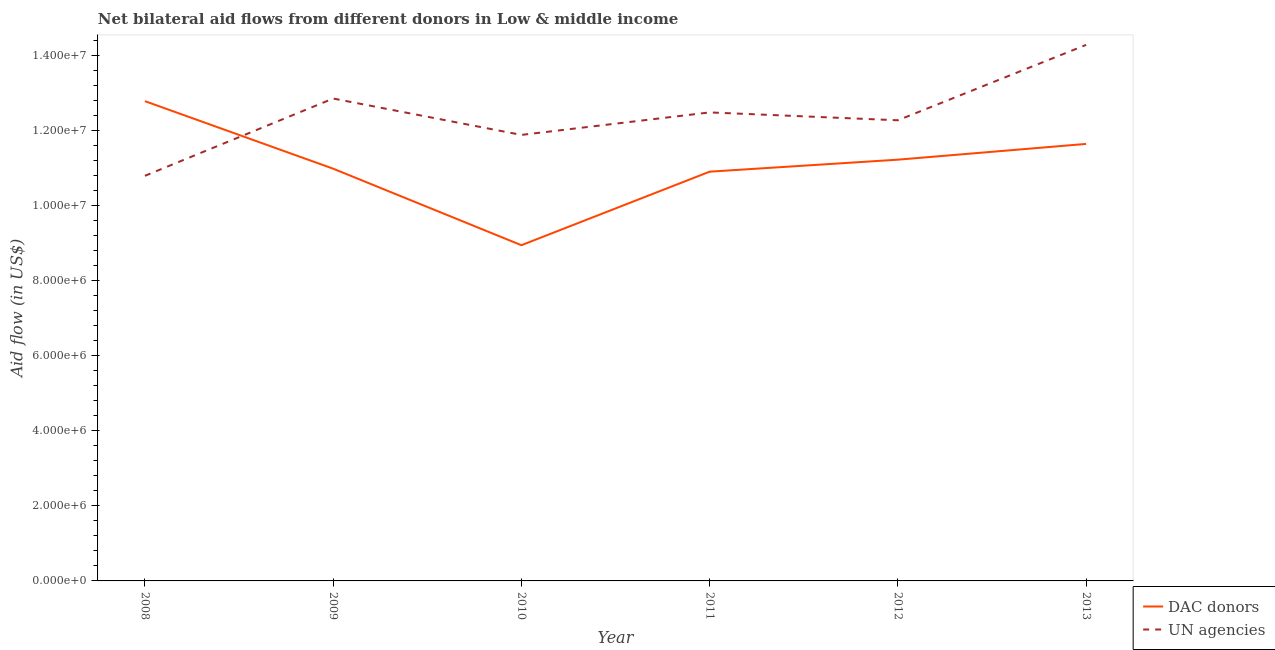How many different coloured lines are there?
Your answer should be compact. 2. What is the aid flow from dac donors in 2009?
Provide a succinct answer. 1.10e+07. Across all years, what is the maximum aid flow from dac donors?
Your answer should be very brief. 1.28e+07. Across all years, what is the minimum aid flow from dac donors?
Make the answer very short. 8.95e+06. In which year was the aid flow from un agencies maximum?
Offer a terse response. 2013. In which year was the aid flow from dac donors minimum?
Give a very brief answer. 2010. What is the total aid flow from un agencies in the graph?
Keep it short and to the point. 7.46e+07. What is the difference between the aid flow from un agencies in 2009 and that in 2010?
Your response must be concise. 9.70e+05. What is the difference between the aid flow from un agencies in 2013 and the aid flow from dac donors in 2010?
Your answer should be very brief. 5.34e+06. What is the average aid flow from un agencies per year?
Give a very brief answer. 1.24e+07. In the year 2013, what is the difference between the aid flow from dac donors and aid flow from un agencies?
Your answer should be very brief. -2.64e+06. What is the ratio of the aid flow from un agencies in 2011 to that in 2013?
Your response must be concise. 0.87. What is the difference between the highest and the second highest aid flow from dac donors?
Your answer should be compact. 1.14e+06. What is the difference between the highest and the lowest aid flow from un agencies?
Your answer should be compact. 3.49e+06. In how many years, is the aid flow from un agencies greater than the average aid flow from un agencies taken over all years?
Your response must be concise. 3. Is the sum of the aid flow from un agencies in 2008 and 2009 greater than the maximum aid flow from dac donors across all years?
Keep it short and to the point. Yes. Does the aid flow from un agencies monotonically increase over the years?
Keep it short and to the point. No. Is the aid flow from dac donors strictly less than the aid flow from un agencies over the years?
Offer a terse response. No. How many years are there in the graph?
Make the answer very short. 6. What is the difference between two consecutive major ticks on the Y-axis?
Provide a short and direct response. 2.00e+06. Are the values on the major ticks of Y-axis written in scientific E-notation?
Provide a succinct answer. Yes. Does the graph contain grids?
Your response must be concise. No. What is the title of the graph?
Offer a very short reply. Net bilateral aid flows from different donors in Low & middle income. Does "Diesel" appear as one of the legend labels in the graph?
Your answer should be compact. No. What is the label or title of the Y-axis?
Give a very brief answer. Aid flow (in US$). What is the Aid flow (in US$) in DAC donors in 2008?
Your response must be concise. 1.28e+07. What is the Aid flow (in US$) in UN agencies in 2008?
Offer a very short reply. 1.08e+07. What is the Aid flow (in US$) in DAC donors in 2009?
Make the answer very short. 1.10e+07. What is the Aid flow (in US$) of UN agencies in 2009?
Your response must be concise. 1.29e+07. What is the Aid flow (in US$) of DAC donors in 2010?
Provide a short and direct response. 8.95e+06. What is the Aid flow (in US$) of UN agencies in 2010?
Make the answer very short. 1.19e+07. What is the Aid flow (in US$) in DAC donors in 2011?
Your response must be concise. 1.09e+07. What is the Aid flow (in US$) in UN agencies in 2011?
Your answer should be very brief. 1.25e+07. What is the Aid flow (in US$) in DAC donors in 2012?
Your answer should be very brief. 1.12e+07. What is the Aid flow (in US$) of UN agencies in 2012?
Provide a succinct answer. 1.23e+07. What is the Aid flow (in US$) in DAC donors in 2013?
Your response must be concise. 1.16e+07. What is the Aid flow (in US$) of UN agencies in 2013?
Offer a very short reply. 1.43e+07. Across all years, what is the maximum Aid flow (in US$) in DAC donors?
Provide a succinct answer. 1.28e+07. Across all years, what is the maximum Aid flow (in US$) of UN agencies?
Give a very brief answer. 1.43e+07. Across all years, what is the minimum Aid flow (in US$) of DAC donors?
Your response must be concise. 8.95e+06. Across all years, what is the minimum Aid flow (in US$) in UN agencies?
Make the answer very short. 1.08e+07. What is the total Aid flow (in US$) of DAC donors in the graph?
Offer a very short reply. 6.65e+07. What is the total Aid flow (in US$) in UN agencies in the graph?
Your answer should be very brief. 7.46e+07. What is the difference between the Aid flow (in US$) of DAC donors in 2008 and that in 2009?
Your response must be concise. 1.80e+06. What is the difference between the Aid flow (in US$) in UN agencies in 2008 and that in 2009?
Keep it short and to the point. -2.06e+06. What is the difference between the Aid flow (in US$) of DAC donors in 2008 and that in 2010?
Your response must be concise. 3.84e+06. What is the difference between the Aid flow (in US$) of UN agencies in 2008 and that in 2010?
Your answer should be compact. -1.09e+06. What is the difference between the Aid flow (in US$) in DAC donors in 2008 and that in 2011?
Your answer should be very brief. 1.88e+06. What is the difference between the Aid flow (in US$) in UN agencies in 2008 and that in 2011?
Give a very brief answer. -1.69e+06. What is the difference between the Aid flow (in US$) of DAC donors in 2008 and that in 2012?
Your answer should be very brief. 1.56e+06. What is the difference between the Aid flow (in US$) of UN agencies in 2008 and that in 2012?
Provide a succinct answer. -1.48e+06. What is the difference between the Aid flow (in US$) in DAC donors in 2008 and that in 2013?
Keep it short and to the point. 1.14e+06. What is the difference between the Aid flow (in US$) in UN agencies in 2008 and that in 2013?
Provide a short and direct response. -3.49e+06. What is the difference between the Aid flow (in US$) of DAC donors in 2009 and that in 2010?
Make the answer very short. 2.04e+06. What is the difference between the Aid flow (in US$) in UN agencies in 2009 and that in 2010?
Offer a very short reply. 9.70e+05. What is the difference between the Aid flow (in US$) in UN agencies in 2009 and that in 2011?
Keep it short and to the point. 3.70e+05. What is the difference between the Aid flow (in US$) in DAC donors in 2009 and that in 2012?
Give a very brief answer. -2.40e+05. What is the difference between the Aid flow (in US$) of UN agencies in 2009 and that in 2012?
Offer a very short reply. 5.80e+05. What is the difference between the Aid flow (in US$) in DAC donors in 2009 and that in 2013?
Your answer should be compact. -6.60e+05. What is the difference between the Aid flow (in US$) in UN agencies in 2009 and that in 2013?
Keep it short and to the point. -1.43e+06. What is the difference between the Aid flow (in US$) in DAC donors in 2010 and that in 2011?
Your response must be concise. -1.96e+06. What is the difference between the Aid flow (in US$) in UN agencies in 2010 and that in 2011?
Keep it short and to the point. -6.00e+05. What is the difference between the Aid flow (in US$) of DAC donors in 2010 and that in 2012?
Your answer should be very brief. -2.28e+06. What is the difference between the Aid flow (in US$) in UN agencies in 2010 and that in 2012?
Ensure brevity in your answer.  -3.90e+05. What is the difference between the Aid flow (in US$) of DAC donors in 2010 and that in 2013?
Your answer should be compact. -2.70e+06. What is the difference between the Aid flow (in US$) in UN agencies in 2010 and that in 2013?
Your answer should be very brief. -2.40e+06. What is the difference between the Aid flow (in US$) of DAC donors in 2011 and that in 2012?
Offer a terse response. -3.20e+05. What is the difference between the Aid flow (in US$) of DAC donors in 2011 and that in 2013?
Make the answer very short. -7.40e+05. What is the difference between the Aid flow (in US$) of UN agencies in 2011 and that in 2013?
Your response must be concise. -1.80e+06. What is the difference between the Aid flow (in US$) of DAC donors in 2012 and that in 2013?
Give a very brief answer. -4.20e+05. What is the difference between the Aid flow (in US$) in UN agencies in 2012 and that in 2013?
Keep it short and to the point. -2.01e+06. What is the difference between the Aid flow (in US$) of DAC donors in 2008 and the Aid flow (in US$) of UN agencies in 2009?
Your answer should be very brief. -7.00e+04. What is the difference between the Aid flow (in US$) in DAC donors in 2008 and the Aid flow (in US$) in UN agencies in 2010?
Offer a very short reply. 9.00e+05. What is the difference between the Aid flow (in US$) in DAC donors in 2008 and the Aid flow (in US$) in UN agencies in 2012?
Your answer should be compact. 5.10e+05. What is the difference between the Aid flow (in US$) in DAC donors in 2008 and the Aid flow (in US$) in UN agencies in 2013?
Your answer should be very brief. -1.50e+06. What is the difference between the Aid flow (in US$) of DAC donors in 2009 and the Aid flow (in US$) of UN agencies in 2010?
Offer a terse response. -9.00e+05. What is the difference between the Aid flow (in US$) in DAC donors in 2009 and the Aid flow (in US$) in UN agencies in 2011?
Your response must be concise. -1.50e+06. What is the difference between the Aid flow (in US$) of DAC donors in 2009 and the Aid flow (in US$) of UN agencies in 2012?
Provide a succinct answer. -1.29e+06. What is the difference between the Aid flow (in US$) of DAC donors in 2009 and the Aid flow (in US$) of UN agencies in 2013?
Your response must be concise. -3.30e+06. What is the difference between the Aid flow (in US$) of DAC donors in 2010 and the Aid flow (in US$) of UN agencies in 2011?
Provide a succinct answer. -3.54e+06. What is the difference between the Aid flow (in US$) of DAC donors in 2010 and the Aid flow (in US$) of UN agencies in 2012?
Make the answer very short. -3.33e+06. What is the difference between the Aid flow (in US$) of DAC donors in 2010 and the Aid flow (in US$) of UN agencies in 2013?
Give a very brief answer. -5.34e+06. What is the difference between the Aid flow (in US$) in DAC donors in 2011 and the Aid flow (in US$) in UN agencies in 2012?
Make the answer very short. -1.37e+06. What is the difference between the Aid flow (in US$) of DAC donors in 2011 and the Aid flow (in US$) of UN agencies in 2013?
Offer a very short reply. -3.38e+06. What is the difference between the Aid flow (in US$) in DAC donors in 2012 and the Aid flow (in US$) in UN agencies in 2013?
Offer a very short reply. -3.06e+06. What is the average Aid flow (in US$) in DAC donors per year?
Your answer should be compact. 1.11e+07. What is the average Aid flow (in US$) in UN agencies per year?
Provide a short and direct response. 1.24e+07. In the year 2008, what is the difference between the Aid flow (in US$) in DAC donors and Aid flow (in US$) in UN agencies?
Your answer should be compact. 1.99e+06. In the year 2009, what is the difference between the Aid flow (in US$) of DAC donors and Aid flow (in US$) of UN agencies?
Give a very brief answer. -1.87e+06. In the year 2010, what is the difference between the Aid flow (in US$) of DAC donors and Aid flow (in US$) of UN agencies?
Provide a succinct answer. -2.94e+06. In the year 2011, what is the difference between the Aid flow (in US$) in DAC donors and Aid flow (in US$) in UN agencies?
Provide a short and direct response. -1.58e+06. In the year 2012, what is the difference between the Aid flow (in US$) of DAC donors and Aid flow (in US$) of UN agencies?
Keep it short and to the point. -1.05e+06. In the year 2013, what is the difference between the Aid flow (in US$) in DAC donors and Aid flow (in US$) in UN agencies?
Your response must be concise. -2.64e+06. What is the ratio of the Aid flow (in US$) of DAC donors in 2008 to that in 2009?
Keep it short and to the point. 1.16. What is the ratio of the Aid flow (in US$) in UN agencies in 2008 to that in 2009?
Your answer should be compact. 0.84. What is the ratio of the Aid flow (in US$) of DAC donors in 2008 to that in 2010?
Your response must be concise. 1.43. What is the ratio of the Aid flow (in US$) in UN agencies in 2008 to that in 2010?
Offer a very short reply. 0.91. What is the ratio of the Aid flow (in US$) of DAC donors in 2008 to that in 2011?
Make the answer very short. 1.17. What is the ratio of the Aid flow (in US$) of UN agencies in 2008 to that in 2011?
Ensure brevity in your answer.  0.86. What is the ratio of the Aid flow (in US$) in DAC donors in 2008 to that in 2012?
Provide a succinct answer. 1.14. What is the ratio of the Aid flow (in US$) in UN agencies in 2008 to that in 2012?
Offer a very short reply. 0.88. What is the ratio of the Aid flow (in US$) in DAC donors in 2008 to that in 2013?
Provide a short and direct response. 1.1. What is the ratio of the Aid flow (in US$) in UN agencies in 2008 to that in 2013?
Keep it short and to the point. 0.76. What is the ratio of the Aid flow (in US$) in DAC donors in 2009 to that in 2010?
Your response must be concise. 1.23. What is the ratio of the Aid flow (in US$) of UN agencies in 2009 to that in 2010?
Your answer should be very brief. 1.08. What is the ratio of the Aid flow (in US$) in DAC donors in 2009 to that in 2011?
Ensure brevity in your answer.  1.01. What is the ratio of the Aid flow (in US$) in UN agencies in 2009 to that in 2011?
Provide a short and direct response. 1.03. What is the ratio of the Aid flow (in US$) of DAC donors in 2009 to that in 2012?
Your answer should be very brief. 0.98. What is the ratio of the Aid flow (in US$) of UN agencies in 2009 to that in 2012?
Provide a succinct answer. 1.05. What is the ratio of the Aid flow (in US$) in DAC donors in 2009 to that in 2013?
Keep it short and to the point. 0.94. What is the ratio of the Aid flow (in US$) in UN agencies in 2009 to that in 2013?
Keep it short and to the point. 0.9. What is the ratio of the Aid flow (in US$) of DAC donors in 2010 to that in 2011?
Your response must be concise. 0.82. What is the ratio of the Aid flow (in US$) of DAC donors in 2010 to that in 2012?
Your response must be concise. 0.8. What is the ratio of the Aid flow (in US$) in UN agencies in 2010 to that in 2012?
Keep it short and to the point. 0.97. What is the ratio of the Aid flow (in US$) in DAC donors in 2010 to that in 2013?
Offer a very short reply. 0.77. What is the ratio of the Aid flow (in US$) in UN agencies in 2010 to that in 2013?
Offer a terse response. 0.83. What is the ratio of the Aid flow (in US$) in DAC donors in 2011 to that in 2012?
Your answer should be compact. 0.97. What is the ratio of the Aid flow (in US$) of UN agencies in 2011 to that in 2012?
Your answer should be compact. 1.02. What is the ratio of the Aid flow (in US$) of DAC donors in 2011 to that in 2013?
Offer a very short reply. 0.94. What is the ratio of the Aid flow (in US$) of UN agencies in 2011 to that in 2013?
Provide a short and direct response. 0.87. What is the ratio of the Aid flow (in US$) of DAC donors in 2012 to that in 2013?
Provide a succinct answer. 0.96. What is the ratio of the Aid flow (in US$) in UN agencies in 2012 to that in 2013?
Offer a terse response. 0.86. What is the difference between the highest and the second highest Aid flow (in US$) of DAC donors?
Ensure brevity in your answer.  1.14e+06. What is the difference between the highest and the second highest Aid flow (in US$) in UN agencies?
Provide a short and direct response. 1.43e+06. What is the difference between the highest and the lowest Aid flow (in US$) of DAC donors?
Offer a terse response. 3.84e+06. What is the difference between the highest and the lowest Aid flow (in US$) in UN agencies?
Keep it short and to the point. 3.49e+06. 